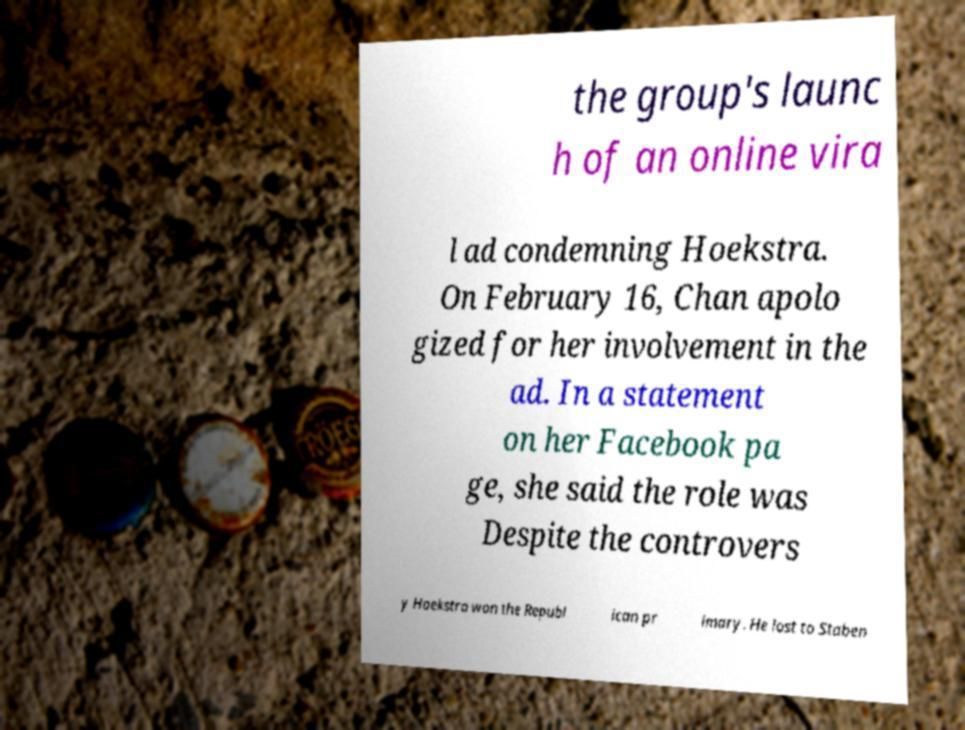I need the written content from this picture converted into text. Can you do that? the group's launc h of an online vira l ad condemning Hoekstra. On February 16, Chan apolo gized for her involvement in the ad. In a statement on her Facebook pa ge, she said the role was Despite the controvers y Hoekstra won the Republ ican pr imary. He lost to Staben 